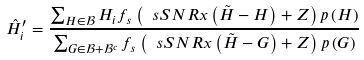<formula> <loc_0><loc_0><loc_500><loc_500>\hat { H } _ { i } ^ { \prime } = \frac { \sum _ { H \in \mathcal { B } } H _ { i } f _ { s } \left ( \ s S N R x \left ( \tilde { H } - H \right ) + Z \right ) p \left ( H \right ) } { \sum _ { G \in \mathcal { B } + \mathcal { B } ^ { c } } f _ { s } \left ( \ s S N R x \left ( \tilde { H } - G \right ) + Z \right ) p \left ( G \right ) }</formula> 